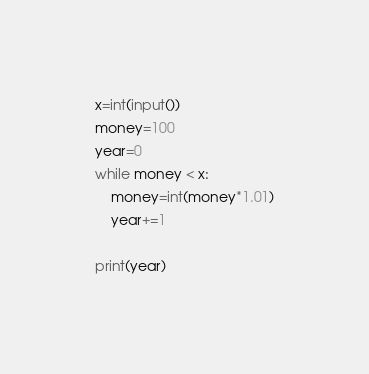<code> <loc_0><loc_0><loc_500><loc_500><_Python_>x=int(input())
money=100
year=0
while money < x:
    money=int(money*1.01)
    year+=1

print(year)</code> 